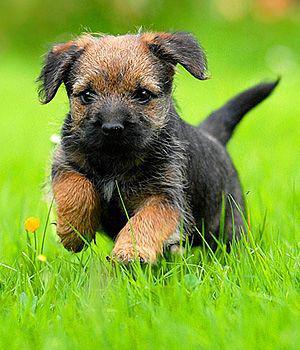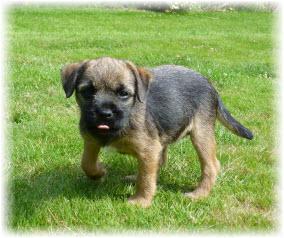The first image is the image on the left, the second image is the image on the right. Examine the images to the left and right. Is the description "Right image shows puppy standing on grass with one paw raised." accurate? Answer yes or no. Yes. The first image is the image on the left, the second image is the image on the right. Evaluate the accuracy of this statement regarding the images: "Two small dogs with floppy ears are in green grassy areas.". Is it true? Answer yes or no. Yes. 